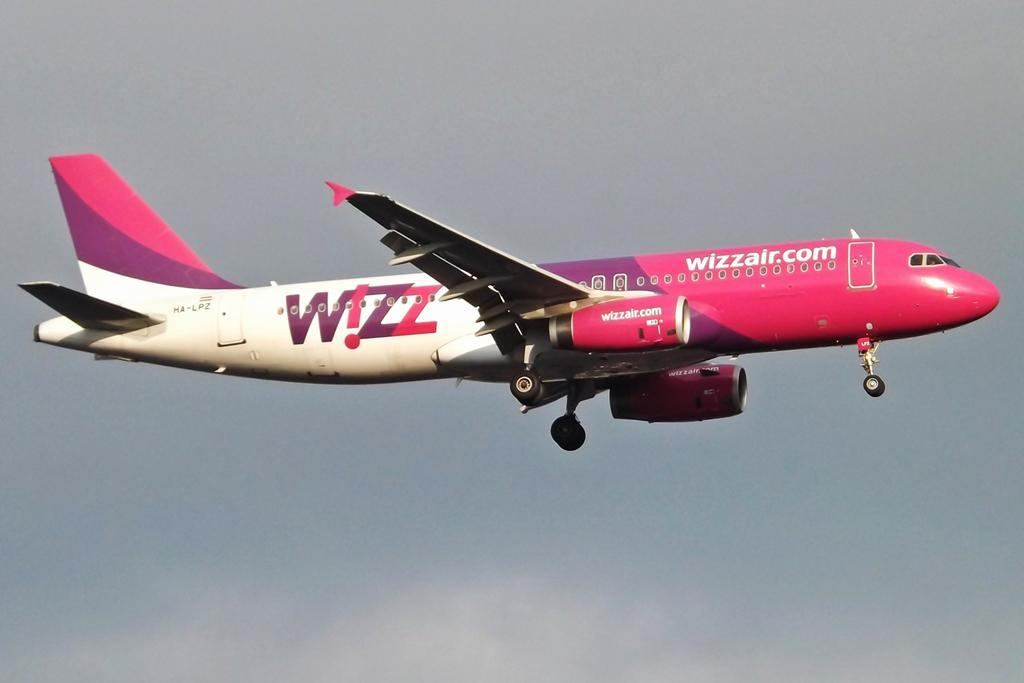<image>
Provide a brief description of the given image. Wizzair.com that is pink, purple, and white on a airplane. 